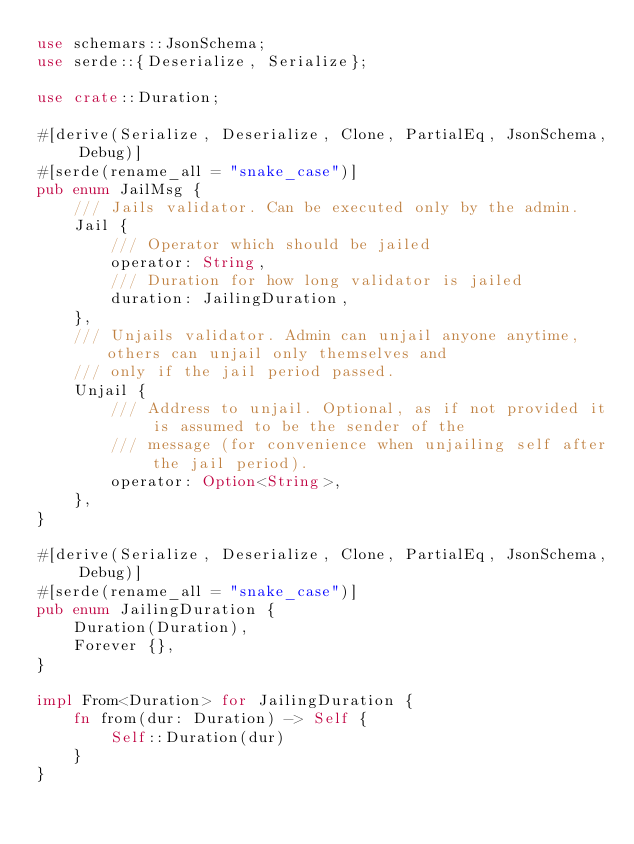Convert code to text. <code><loc_0><loc_0><loc_500><loc_500><_Rust_>use schemars::JsonSchema;
use serde::{Deserialize, Serialize};

use crate::Duration;

#[derive(Serialize, Deserialize, Clone, PartialEq, JsonSchema, Debug)]
#[serde(rename_all = "snake_case")]
pub enum JailMsg {
    /// Jails validator. Can be executed only by the admin.
    Jail {
        /// Operator which should be jailed
        operator: String,
        /// Duration for how long validator is jailed
        duration: JailingDuration,
    },
    /// Unjails validator. Admin can unjail anyone anytime, others can unjail only themselves and
    /// only if the jail period passed.
    Unjail {
        /// Address to unjail. Optional, as if not provided it is assumed to be the sender of the
        /// message (for convenience when unjailing self after the jail period).
        operator: Option<String>,
    },
}

#[derive(Serialize, Deserialize, Clone, PartialEq, JsonSchema, Debug)]
#[serde(rename_all = "snake_case")]
pub enum JailingDuration {
    Duration(Duration),
    Forever {},
}

impl From<Duration> for JailingDuration {
    fn from(dur: Duration) -> Self {
        Self::Duration(dur)
    }
}
</code> 